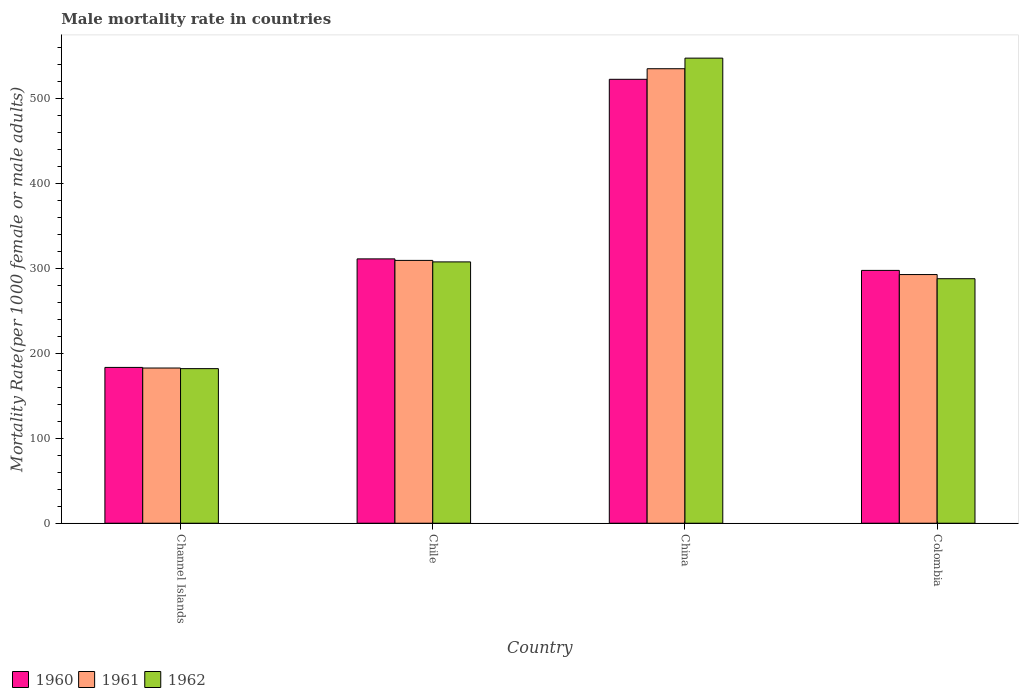How many groups of bars are there?
Your answer should be very brief. 4. Are the number of bars on each tick of the X-axis equal?
Your answer should be very brief. Yes. How many bars are there on the 2nd tick from the left?
Keep it short and to the point. 3. How many bars are there on the 3rd tick from the right?
Offer a very short reply. 3. What is the label of the 3rd group of bars from the left?
Your answer should be compact. China. What is the male mortality rate in 1962 in China?
Give a very brief answer. 547.37. Across all countries, what is the maximum male mortality rate in 1960?
Provide a short and direct response. 522.44. Across all countries, what is the minimum male mortality rate in 1962?
Your answer should be very brief. 181.93. In which country was the male mortality rate in 1960 minimum?
Offer a terse response. Channel Islands. What is the total male mortality rate in 1960 in the graph?
Ensure brevity in your answer.  1314.47. What is the difference between the male mortality rate in 1962 in China and that in Colombia?
Make the answer very short. 259.61. What is the difference between the male mortality rate in 1960 in Chile and the male mortality rate in 1962 in China?
Ensure brevity in your answer.  -236.27. What is the average male mortality rate in 1960 per country?
Ensure brevity in your answer.  328.62. What is the difference between the male mortality rate of/in 1962 and male mortality rate of/in 1960 in China?
Give a very brief answer. 24.93. In how many countries, is the male mortality rate in 1961 greater than 540?
Offer a very short reply. 0. What is the ratio of the male mortality rate in 1962 in China to that in Colombia?
Your answer should be compact. 1.9. Is the male mortality rate in 1960 in Chile less than that in China?
Provide a succinct answer. Yes. What is the difference between the highest and the second highest male mortality rate in 1960?
Your answer should be compact. -224.9. What is the difference between the highest and the lowest male mortality rate in 1960?
Your response must be concise. 339.07. In how many countries, is the male mortality rate in 1960 greater than the average male mortality rate in 1960 taken over all countries?
Offer a very short reply. 1. What does the 1st bar from the left in China represents?
Give a very brief answer. 1960. Is it the case that in every country, the sum of the male mortality rate in 1962 and male mortality rate in 1960 is greater than the male mortality rate in 1961?
Keep it short and to the point. Yes. Are all the bars in the graph horizontal?
Provide a short and direct response. No. How many countries are there in the graph?
Offer a very short reply. 4. Are the values on the major ticks of Y-axis written in scientific E-notation?
Your answer should be compact. No. Does the graph contain any zero values?
Give a very brief answer. No. Does the graph contain grids?
Offer a very short reply. No. How many legend labels are there?
Offer a very short reply. 3. How are the legend labels stacked?
Provide a succinct answer. Horizontal. What is the title of the graph?
Keep it short and to the point. Male mortality rate in countries. Does "1986" appear as one of the legend labels in the graph?
Ensure brevity in your answer.  No. What is the label or title of the X-axis?
Your response must be concise. Country. What is the label or title of the Y-axis?
Offer a very short reply. Mortality Rate(per 1000 female or male adults). What is the Mortality Rate(per 1000 female or male adults) of 1960 in Channel Islands?
Make the answer very short. 183.37. What is the Mortality Rate(per 1000 female or male adults) of 1961 in Channel Islands?
Offer a very short reply. 182.65. What is the Mortality Rate(per 1000 female or male adults) of 1962 in Channel Islands?
Your response must be concise. 181.93. What is the Mortality Rate(per 1000 female or male adults) of 1960 in Chile?
Your answer should be very brief. 311.11. What is the Mortality Rate(per 1000 female or male adults) of 1961 in Chile?
Give a very brief answer. 309.33. What is the Mortality Rate(per 1000 female or male adults) of 1962 in Chile?
Ensure brevity in your answer.  307.55. What is the Mortality Rate(per 1000 female or male adults) of 1960 in China?
Your response must be concise. 522.44. What is the Mortality Rate(per 1000 female or male adults) of 1961 in China?
Keep it short and to the point. 534.91. What is the Mortality Rate(per 1000 female or male adults) of 1962 in China?
Provide a short and direct response. 547.37. What is the Mortality Rate(per 1000 female or male adults) in 1960 in Colombia?
Keep it short and to the point. 297.54. What is the Mortality Rate(per 1000 female or male adults) in 1961 in Colombia?
Your response must be concise. 292.65. What is the Mortality Rate(per 1000 female or male adults) of 1962 in Colombia?
Make the answer very short. 287.76. Across all countries, what is the maximum Mortality Rate(per 1000 female or male adults) of 1960?
Provide a short and direct response. 522.44. Across all countries, what is the maximum Mortality Rate(per 1000 female or male adults) of 1961?
Offer a very short reply. 534.91. Across all countries, what is the maximum Mortality Rate(per 1000 female or male adults) of 1962?
Your answer should be very brief. 547.37. Across all countries, what is the minimum Mortality Rate(per 1000 female or male adults) of 1960?
Give a very brief answer. 183.37. Across all countries, what is the minimum Mortality Rate(per 1000 female or male adults) in 1961?
Keep it short and to the point. 182.65. Across all countries, what is the minimum Mortality Rate(per 1000 female or male adults) in 1962?
Ensure brevity in your answer.  181.93. What is the total Mortality Rate(per 1000 female or male adults) of 1960 in the graph?
Your answer should be compact. 1314.47. What is the total Mortality Rate(per 1000 female or male adults) in 1961 in the graph?
Your answer should be very brief. 1319.54. What is the total Mortality Rate(per 1000 female or male adults) in 1962 in the graph?
Give a very brief answer. 1324.61. What is the difference between the Mortality Rate(per 1000 female or male adults) of 1960 in Channel Islands and that in Chile?
Offer a very short reply. -127.73. What is the difference between the Mortality Rate(per 1000 female or male adults) of 1961 in Channel Islands and that in Chile?
Give a very brief answer. -126.67. What is the difference between the Mortality Rate(per 1000 female or male adults) of 1962 in Channel Islands and that in Chile?
Give a very brief answer. -125.62. What is the difference between the Mortality Rate(per 1000 female or male adults) in 1960 in Channel Islands and that in China?
Your answer should be compact. -339.07. What is the difference between the Mortality Rate(per 1000 female or male adults) of 1961 in Channel Islands and that in China?
Make the answer very short. -352.26. What is the difference between the Mortality Rate(per 1000 female or male adults) in 1962 in Channel Islands and that in China?
Your answer should be compact. -365.44. What is the difference between the Mortality Rate(per 1000 female or male adults) of 1960 in Channel Islands and that in Colombia?
Keep it short and to the point. -114.17. What is the difference between the Mortality Rate(per 1000 female or male adults) of 1961 in Channel Islands and that in Colombia?
Make the answer very short. -110. What is the difference between the Mortality Rate(per 1000 female or male adults) of 1962 in Channel Islands and that in Colombia?
Offer a very short reply. -105.84. What is the difference between the Mortality Rate(per 1000 female or male adults) of 1960 in Chile and that in China?
Provide a succinct answer. -211.34. What is the difference between the Mortality Rate(per 1000 female or male adults) in 1961 in Chile and that in China?
Offer a very short reply. -225.58. What is the difference between the Mortality Rate(per 1000 female or male adults) of 1962 in Chile and that in China?
Ensure brevity in your answer.  -239.82. What is the difference between the Mortality Rate(per 1000 female or male adults) of 1960 in Chile and that in Colombia?
Your answer should be compact. 13.56. What is the difference between the Mortality Rate(per 1000 female or male adults) of 1961 in Chile and that in Colombia?
Your answer should be compact. 16.67. What is the difference between the Mortality Rate(per 1000 female or male adults) in 1962 in Chile and that in Colombia?
Your response must be concise. 19.78. What is the difference between the Mortality Rate(per 1000 female or male adults) of 1960 in China and that in Colombia?
Your answer should be compact. 224.9. What is the difference between the Mortality Rate(per 1000 female or male adults) of 1961 in China and that in Colombia?
Provide a succinct answer. 242.25. What is the difference between the Mortality Rate(per 1000 female or male adults) in 1962 in China and that in Colombia?
Provide a short and direct response. 259.61. What is the difference between the Mortality Rate(per 1000 female or male adults) in 1960 in Channel Islands and the Mortality Rate(per 1000 female or male adults) in 1961 in Chile?
Keep it short and to the point. -125.95. What is the difference between the Mortality Rate(per 1000 female or male adults) in 1960 in Channel Islands and the Mortality Rate(per 1000 female or male adults) in 1962 in Chile?
Keep it short and to the point. -124.17. What is the difference between the Mortality Rate(per 1000 female or male adults) of 1961 in Channel Islands and the Mortality Rate(per 1000 female or male adults) of 1962 in Chile?
Offer a very short reply. -124.9. What is the difference between the Mortality Rate(per 1000 female or male adults) of 1960 in Channel Islands and the Mortality Rate(per 1000 female or male adults) of 1961 in China?
Your answer should be compact. -351.53. What is the difference between the Mortality Rate(per 1000 female or male adults) in 1960 in Channel Islands and the Mortality Rate(per 1000 female or male adults) in 1962 in China?
Make the answer very short. -364. What is the difference between the Mortality Rate(per 1000 female or male adults) in 1961 in Channel Islands and the Mortality Rate(per 1000 female or male adults) in 1962 in China?
Your answer should be very brief. -364.72. What is the difference between the Mortality Rate(per 1000 female or male adults) in 1960 in Channel Islands and the Mortality Rate(per 1000 female or male adults) in 1961 in Colombia?
Ensure brevity in your answer.  -109.28. What is the difference between the Mortality Rate(per 1000 female or male adults) in 1960 in Channel Islands and the Mortality Rate(per 1000 female or male adults) in 1962 in Colombia?
Offer a terse response. -104.39. What is the difference between the Mortality Rate(per 1000 female or male adults) of 1961 in Channel Islands and the Mortality Rate(per 1000 female or male adults) of 1962 in Colombia?
Make the answer very short. -105.11. What is the difference between the Mortality Rate(per 1000 female or male adults) in 1960 in Chile and the Mortality Rate(per 1000 female or male adults) in 1961 in China?
Ensure brevity in your answer.  -223.8. What is the difference between the Mortality Rate(per 1000 female or male adults) of 1960 in Chile and the Mortality Rate(per 1000 female or male adults) of 1962 in China?
Your answer should be compact. -236.27. What is the difference between the Mortality Rate(per 1000 female or male adults) of 1961 in Chile and the Mortality Rate(per 1000 female or male adults) of 1962 in China?
Ensure brevity in your answer.  -238.05. What is the difference between the Mortality Rate(per 1000 female or male adults) of 1960 in Chile and the Mortality Rate(per 1000 female or male adults) of 1961 in Colombia?
Offer a very short reply. 18.45. What is the difference between the Mortality Rate(per 1000 female or male adults) of 1960 in Chile and the Mortality Rate(per 1000 female or male adults) of 1962 in Colombia?
Provide a succinct answer. 23.34. What is the difference between the Mortality Rate(per 1000 female or male adults) of 1961 in Chile and the Mortality Rate(per 1000 female or male adults) of 1962 in Colombia?
Your answer should be compact. 21.56. What is the difference between the Mortality Rate(per 1000 female or male adults) in 1960 in China and the Mortality Rate(per 1000 female or male adults) in 1961 in Colombia?
Your answer should be very brief. 229.79. What is the difference between the Mortality Rate(per 1000 female or male adults) of 1960 in China and the Mortality Rate(per 1000 female or male adults) of 1962 in Colombia?
Offer a very short reply. 234.68. What is the difference between the Mortality Rate(per 1000 female or male adults) in 1961 in China and the Mortality Rate(per 1000 female or male adults) in 1962 in Colombia?
Your answer should be very brief. 247.14. What is the average Mortality Rate(per 1000 female or male adults) of 1960 per country?
Provide a short and direct response. 328.62. What is the average Mortality Rate(per 1000 female or male adults) in 1961 per country?
Give a very brief answer. 329.88. What is the average Mortality Rate(per 1000 female or male adults) of 1962 per country?
Your answer should be very brief. 331.15. What is the difference between the Mortality Rate(per 1000 female or male adults) of 1960 and Mortality Rate(per 1000 female or male adults) of 1961 in Channel Islands?
Your answer should be compact. 0.72. What is the difference between the Mortality Rate(per 1000 female or male adults) of 1960 and Mortality Rate(per 1000 female or male adults) of 1962 in Channel Islands?
Offer a terse response. 1.45. What is the difference between the Mortality Rate(per 1000 female or male adults) in 1961 and Mortality Rate(per 1000 female or male adults) in 1962 in Channel Islands?
Offer a very short reply. 0.72. What is the difference between the Mortality Rate(per 1000 female or male adults) of 1960 and Mortality Rate(per 1000 female or male adults) of 1961 in Chile?
Ensure brevity in your answer.  1.78. What is the difference between the Mortality Rate(per 1000 female or male adults) of 1960 and Mortality Rate(per 1000 female or male adults) of 1962 in Chile?
Ensure brevity in your answer.  3.56. What is the difference between the Mortality Rate(per 1000 female or male adults) in 1961 and Mortality Rate(per 1000 female or male adults) in 1962 in Chile?
Provide a succinct answer. 1.78. What is the difference between the Mortality Rate(per 1000 female or male adults) in 1960 and Mortality Rate(per 1000 female or male adults) in 1961 in China?
Your answer should be very brief. -12.46. What is the difference between the Mortality Rate(per 1000 female or male adults) in 1960 and Mortality Rate(per 1000 female or male adults) in 1962 in China?
Your answer should be very brief. -24.93. What is the difference between the Mortality Rate(per 1000 female or male adults) of 1961 and Mortality Rate(per 1000 female or male adults) of 1962 in China?
Offer a terse response. -12.46. What is the difference between the Mortality Rate(per 1000 female or male adults) of 1960 and Mortality Rate(per 1000 female or male adults) of 1961 in Colombia?
Give a very brief answer. 4.89. What is the difference between the Mortality Rate(per 1000 female or male adults) of 1960 and Mortality Rate(per 1000 female or male adults) of 1962 in Colombia?
Ensure brevity in your answer.  9.78. What is the difference between the Mortality Rate(per 1000 female or male adults) of 1961 and Mortality Rate(per 1000 female or male adults) of 1962 in Colombia?
Give a very brief answer. 4.89. What is the ratio of the Mortality Rate(per 1000 female or male adults) of 1960 in Channel Islands to that in Chile?
Provide a short and direct response. 0.59. What is the ratio of the Mortality Rate(per 1000 female or male adults) in 1961 in Channel Islands to that in Chile?
Ensure brevity in your answer.  0.59. What is the ratio of the Mortality Rate(per 1000 female or male adults) of 1962 in Channel Islands to that in Chile?
Your answer should be very brief. 0.59. What is the ratio of the Mortality Rate(per 1000 female or male adults) in 1960 in Channel Islands to that in China?
Give a very brief answer. 0.35. What is the ratio of the Mortality Rate(per 1000 female or male adults) in 1961 in Channel Islands to that in China?
Your answer should be very brief. 0.34. What is the ratio of the Mortality Rate(per 1000 female or male adults) in 1962 in Channel Islands to that in China?
Your response must be concise. 0.33. What is the ratio of the Mortality Rate(per 1000 female or male adults) of 1960 in Channel Islands to that in Colombia?
Keep it short and to the point. 0.62. What is the ratio of the Mortality Rate(per 1000 female or male adults) in 1961 in Channel Islands to that in Colombia?
Provide a succinct answer. 0.62. What is the ratio of the Mortality Rate(per 1000 female or male adults) of 1962 in Channel Islands to that in Colombia?
Provide a succinct answer. 0.63. What is the ratio of the Mortality Rate(per 1000 female or male adults) in 1960 in Chile to that in China?
Your answer should be compact. 0.6. What is the ratio of the Mortality Rate(per 1000 female or male adults) of 1961 in Chile to that in China?
Give a very brief answer. 0.58. What is the ratio of the Mortality Rate(per 1000 female or male adults) in 1962 in Chile to that in China?
Your answer should be compact. 0.56. What is the ratio of the Mortality Rate(per 1000 female or male adults) of 1960 in Chile to that in Colombia?
Your answer should be very brief. 1.05. What is the ratio of the Mortality Rate(per 1000 female or male adults) in 1961 in Chile to that in Colombia?
Offer a very short reply. 1.06. What is the ratio of the Mortality Rate(per 1000 female or male adults) in 1962 in Chile to that in Colombia?
Make the answer very short. 1.07. What is the ratio of the Mortality Rate(per 1000 female or male adults) of 1960 in China to that in Colombia?
Your response must be concise. 1.76. What is the ratio of the Mortality Rate(per 1000 female or male adults) of 1961 in China to that in Colombia?
Give a very brief answer. 1.83. What is the ratio of the Mortality Rate(per 1000 female or male adults) in 1962 in China to that in Colombia?
Your answer should be compact. 1.9. What is the difference between the highest and the second highest Mortality Rate(per 1000 female or male adults) of 1960?
Keep it short and to the point. 211.34. What is the difference between the highest and the second highest Mortality Rate(per 1000 female or male adults) in 1961?
Your response must be concise. 225.58. What is the difference between the highest and the second highest Mortality Rate(per 1000 female or male adults) of 1962?
Provide a short and direct response. 239.82. What is the difference between the highest and the lowest Mortality Rate(per 1000 female or male adults) in 1960?
Provide a short and direct response. 339.07. What is the difference between the highest and the lowest Mortality Rate(per 1000 female or male adults) in 1961?
Your answer should be very brief. 352.26. What is the difference between the highest and the lowest Mortality Rate(per 1000 female or male adults) of 1962?
Provide a short and direct response. 365.44. 